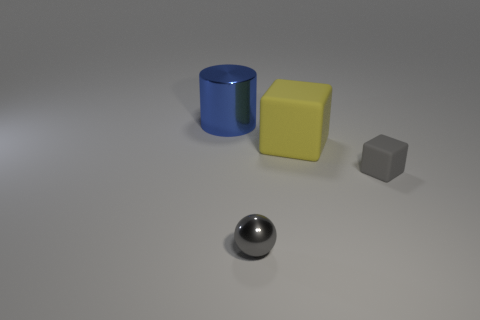Is there any other thing of the same color as the metallic cylinder? While the cylindrical object has a distinct metallic sheen, nothing else in the image shares the exact color and finish. However, the smaller cube has a similar monotone color, albeit with a matte finish and a lighter shade. 